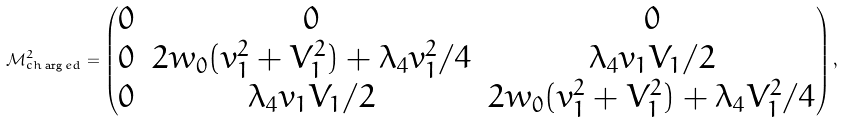Convert formula to latex. <formula><loc_0><loc_0><loc_500><loc_500>\mathcal { M } ^ { 2 } _ { c h \arg e d } = \begin{pmatrix} 0 & 0 & 0 \\ 0 & 2 w _ { 0 } ( v _ { 1 } ^ { 2 } + V _ { 1 } ^ { 2 } ) + \lambda _ { 4 } v _ { 1 } ^ { 2 } / 4 & \lambda _ { 4 } v _ { 1 } V _ { 1 } / 2 \\ 0 & \lambda _ { 4 } v _ { 1 } V _ { 1 } / 2 & 2 w _ { 0 } ( v _ { 1 } ^ { 2 } + V _ { 1 } ^ { 2 } ) + \lambda _ { 4 } V _ { 1 } ^ { 2 } / 4 \end{pmatrix} ,</formula> 